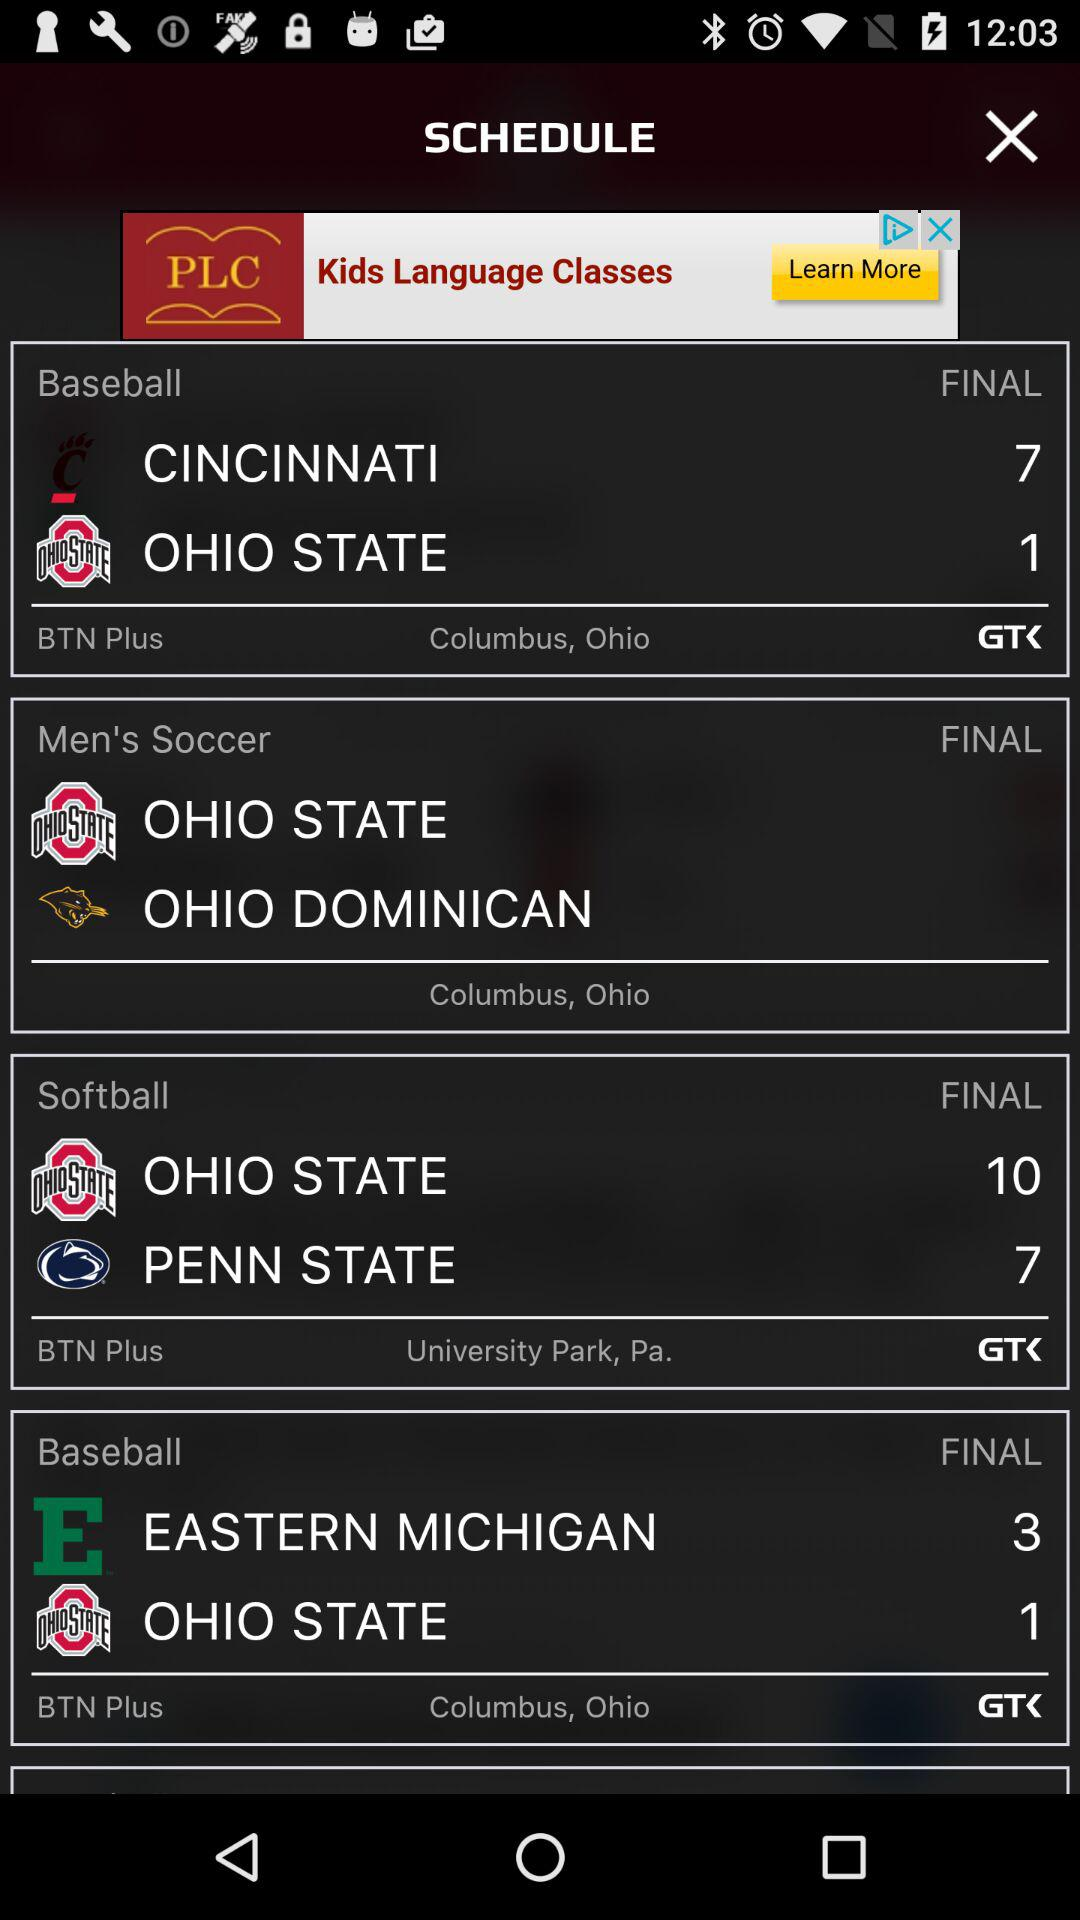How many more teams are playing baseball than softball?
Answer the question using a single word or phrase. 1 